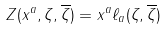<formula> <loc_0><loc_0><loc_500><loc_500>Z ( x ^ { a } , \zeta , \overline { \zeta } ) = x ^ { a } \ell _ { a } ( \zeta , \overline { \zeta } )</formula> 